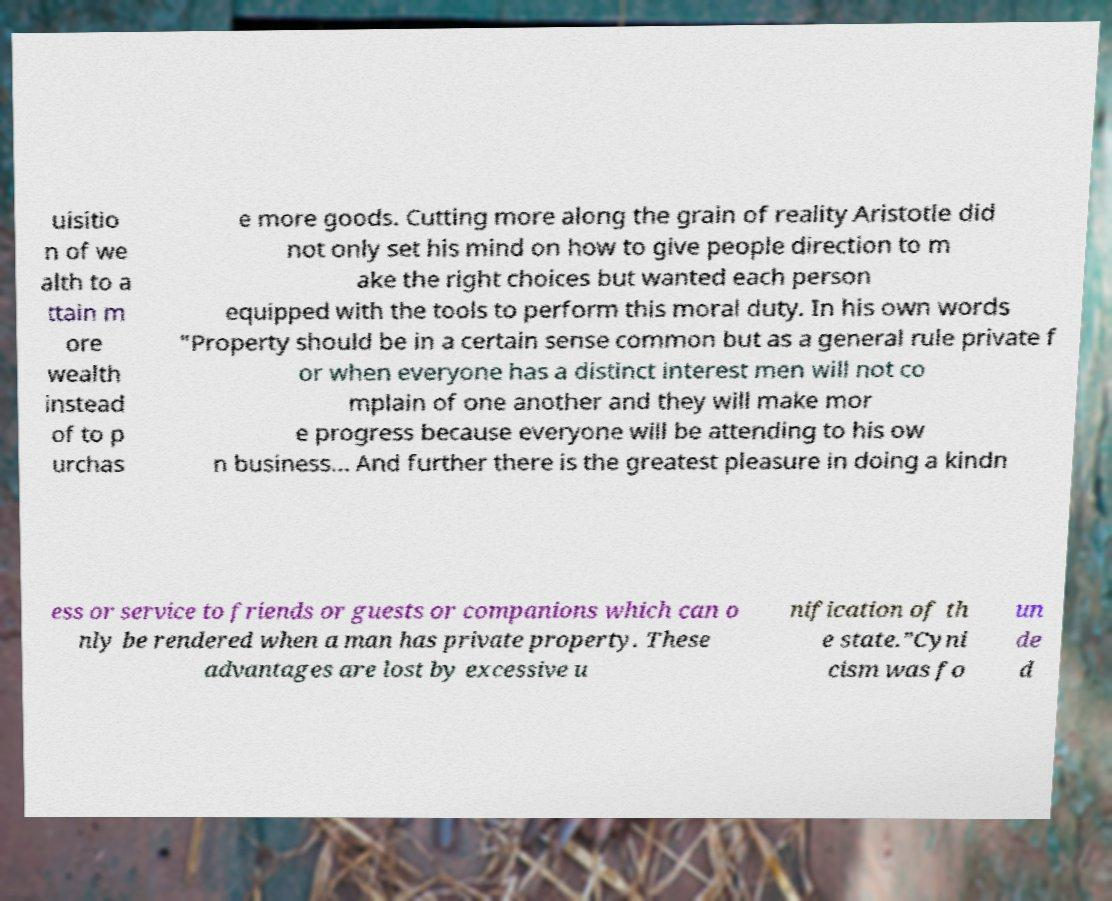There's text embedded in this image that I need extracted. Can you transcribe it verbatim? uisitio n of we alth to a ttain m ore wealth instead of to p urchas e more goods. Cutting more along the grain of reality Aristotle did not only set his mind on how to give people direction to m ake the right choices but wanted each person equipped with the tools to perform this moral duty. In his own words "Property should be in a certain sense common but as a general rule private f or when everyone has a distinct interest men will not co mplain of one another and they will make mor e progress because everyone will be attending to his ow n business... And further there is the greatest pleasure in doing a kindn ess or service to friends or guests or companions which can o nly be rendered when a man has private property. These advantages are lost by excessive u nification of th e state.”Cyni cism was fo un de d 